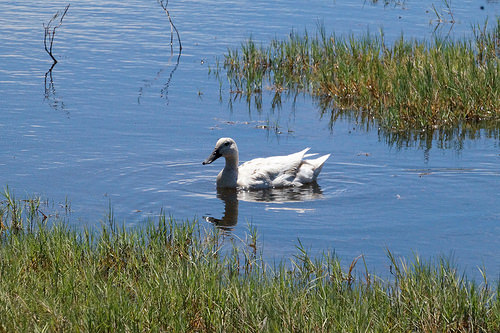<image>
Can you confirm if the duck is on the grass? No. The duck is not positioned on the grass. They may be near each other, but the duck is not supported by or resting on top of the grass. Where is the duck in relation to the grass? Is it in the grass? No. The duck is not contained within the grass. These objects have a different spatial relationship. 